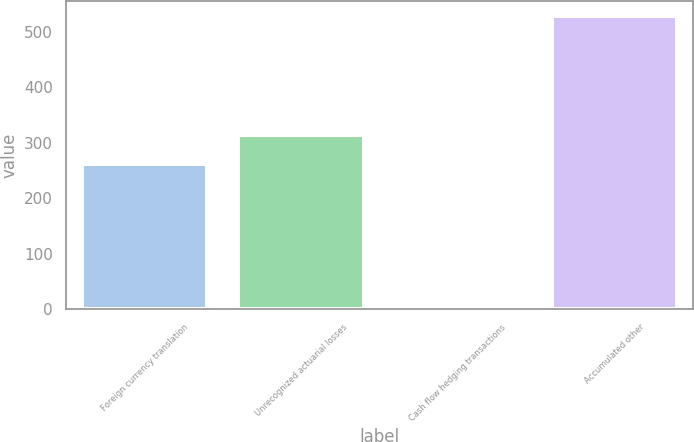Convert chart. <chart><loc_0><loc_0><loc_500><loc_500><bar_chart><fcel>Foreign currency translation<fcel>Unrecognized actuarial losses<fcel>Cash flow hedging transactions<fcel>Accumulated other<nl><fcel>262<fcel>314.79<fcel>1<fcel>528.9<nl></chart> 